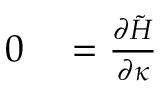<formula> <loc_0><loc_0><loc_500><loc_500>\begin{array} { r l } { 0 } & = \frac { \partial \tilde { H } } { \partial \kappa } } \end{array}</formula> 